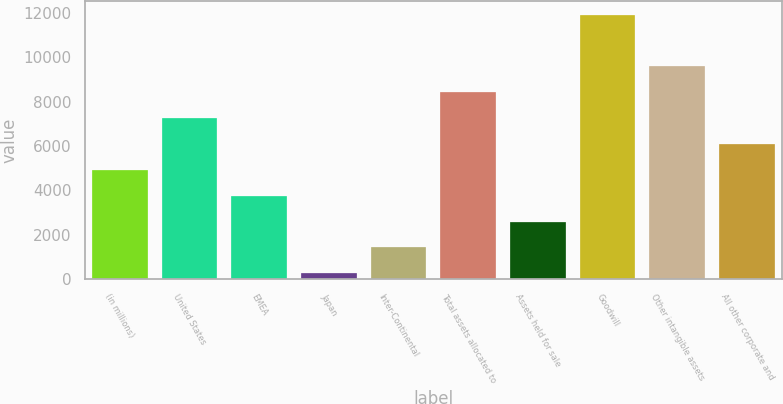Convert chart to OTSL. <chart><loc_0><loc_0><loc_500><loc_500><bar_chart><fcel>(in millions)<fcel>United States<fcel>EMEA<fcel>Japan<fcel>Inter-Continental<fcel>Total assets allocated to<fcel>Assets held for sale<fcel>Goodwill<fcel>Other intangible assets<fcel>All other corporate and<nl><fcel>4928.6<fcel>7264.4<fcel>3760.7<fcel>257<fcel>1424.9<fcel>8432.3<fcel>2592.8<fcel>11936<fcel>9600.2<fcel>6096.5<nl></chart> 